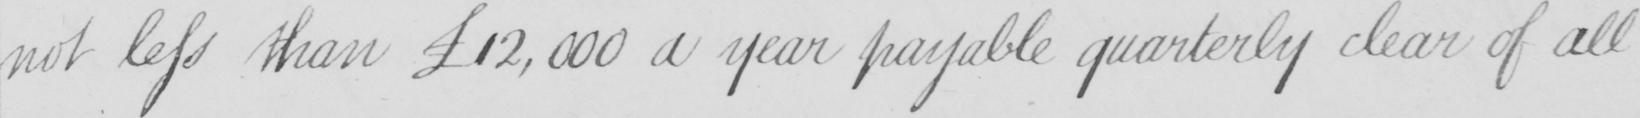What does this handwritten line say? not less than £12,000 a year payable quarterly clear of all 